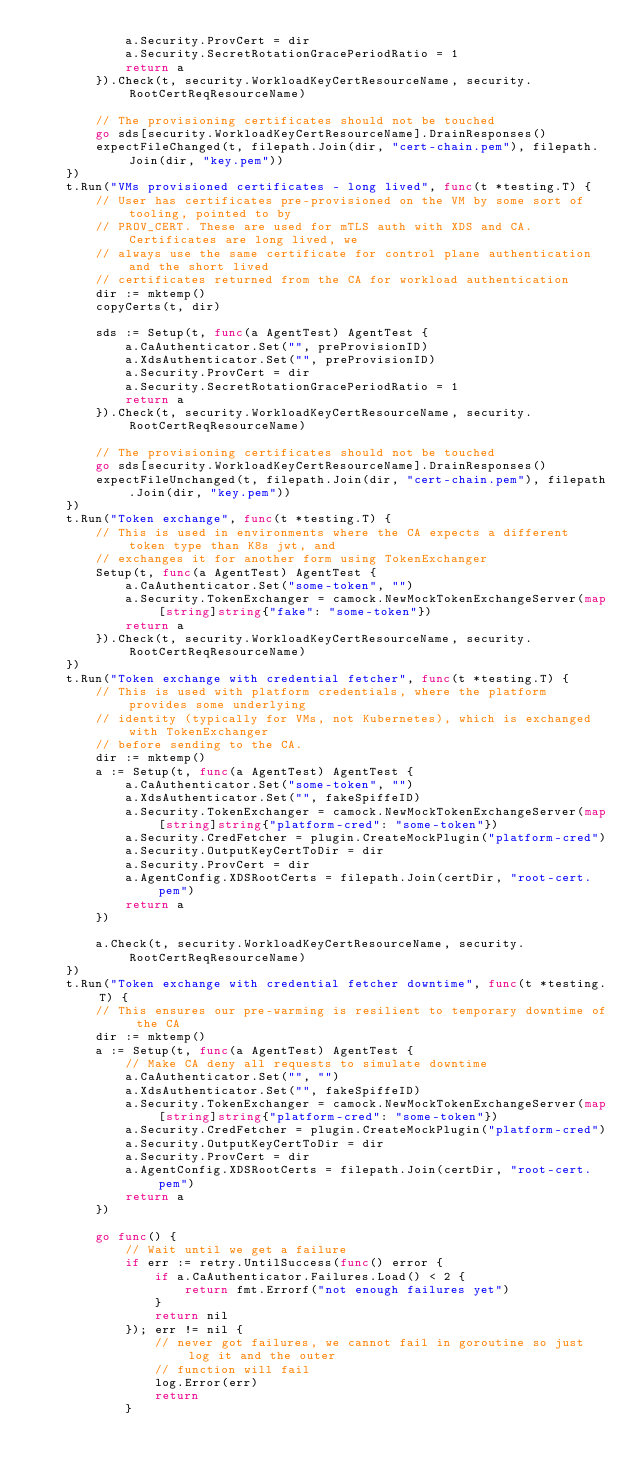<code> <loc_0><loc_0><loc_500><loc_500><_Go_>			a.Security.ProvCert = dir
			a.Security.SecretRotationGracePeriodRatio = 1
			return a
		}).Check(t, security.WorkloadKeyCertResourceName, security.RootCertReqResourceName)

		// The provisioning certificates should not be touched
		go sds[security.WorkloadKeyCertResourceName].DrainResponses()
		expectFileChanged(t, filepath.Join(dir, "cert-chain.pem"), filepath.Join(dir, "key.pem"))
	})
	t.Run("VMs provisioned certificates - long lived", func(t *testing.T) {
		// User has certificates pre-provisioned on the VM by some sort of tooling, pointed to by
		// PROV_CERT. These are used for mTLS auth with XDS and CA. Certificates are long lived, we
		// always use the same certificate for control plane authentication and the short lived
		// certificates returned from the CA for workload authentication
		dir := mktemp()
		copyCerts(t, dir)

		sds := Setup(t, func(a AgentTest) AgentTest {
			a.CaAuthenticator.Set("", preProvisionID)
			a.XdsAuthenticator.Set("", preProvisionID)
			a.Security.ProvCert = dir
			a.Security.SecretRotationGracePeriodRatio = 1
			return a
		}).Check(t, security.WorkloadKeyCertResourceName, security.RootCertReqResourceName)

		// The provisioning certificates should not be touched
		go sds[security.WorkloadKeyCertResourceName].DrainResponses()
		expectFileUnchanged(t, filepath.Join(dir, "cert-chain.pem"), filepath.Join(dir, "key.pem"))
	})
	t.Run("Token exchange", func(t *testing.T) {
		// This is used in environments where the CA expects a different token type than K8s jwt, and
		// exchanges it for another form using TokenExchanger
		Setup(t, func(a AgentTest) AgentTest {
			a.CaAuthenticator.Set("some-token", "")
			a.Security.TokenExchanger = camock.NewMockTokenExchangeServer(map[string]string{"fake": "some-token"})
			return a
		}).Check(t, security.WorkloadKeyCertResourceName, security.RootCertReqResourceName)
	})
	t.Run("Token exchange with credential fetcher", func(t *testing.T) {
		// This is used with platform credentials, where the platform provides some underlying
		// identity (typically for VMs, not Kubernetes), which is exchanged with TokenExchanger
		// before sending to the CA.
		dir := mktemp()
		a := Setup(t, func(a AgentTest) AgentTest {
			a.CaAuthenticator.Set("some-token", "")
			a.XdsAuthenticator.Set("", fakeSpiffeID)
			a.Security.TokenExchanger = camock.NewMockTokenExchangeServer(map[string]string{"platform-cred": "some-token"})
			a.Security.CredFetcher = plugin.CreateMockPlugin("platform-cred")
			a.Security.OutputKeyCertToDir = dir
			a.Security.ProvCert = dir
			a.AgentConfig.XDSRootCerts = filepath.Join(certDir, "root-cert.pem")
			return a
		})

		a.Check(t, security.WorkloadKeyCertResourceName, security.RootCertReqResourceName)
	})
	t.Run("Token exchange with credential fetcher downtime", func(t *testing.T) {
		// This ensures our pre-warming is resilient to temporary downtime of the CA
		dir := mktemp()
		a := Setup(t, func(a AgentTest) AgentTest {
			// Make CA deny all requests to simulate downtime
			a.CaAuthenticator.Set("", "")
			a.XdsAuthenticator.Set("", fakeSpiffeID)
			a.Security.TokenExchanger = camock.NewMockTokenExchangeServer(map[string]string{"platform-cred": "some-token"})
			a.Security.CredFetcher = plugin.CreateMockPlugin("platform-cred")
			a.Security.OutputKeyCertToDir = dir
			a.Security.ProvCert = dir
			a.AgentConfig.XDSRootCerts = filepath.Join(certDir, "root-cert.pem")
			return a
		})

		go func() {
			// Wait until we get a failure
			if err := retry.UntilSuccess(func() error {
				if a.CaAuthenticator.Failures.Load() < 2 {
					return fmt.Errorf("not enough failures yet")
				}
				return nil
			}); err != nil {
				// never got failures, we cannot fail in goroutine so just log it and the outer
				// function will fail
				log.Error(err)
				return
			}</code> 